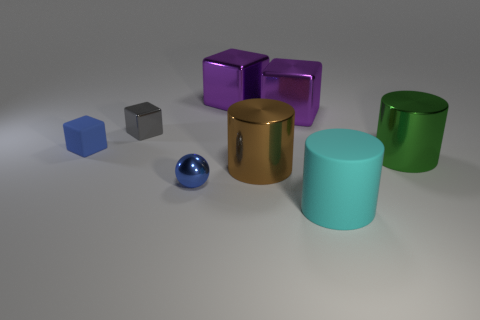Which objects in the image can reflect light well, indicating they might be metallic or shiny? The small blue sphere, the large brown cylinder, and the three colorful cubes seem to reflect light well and give off a shiny appearance, which suggests they might be metallic or have a glossy finish. 